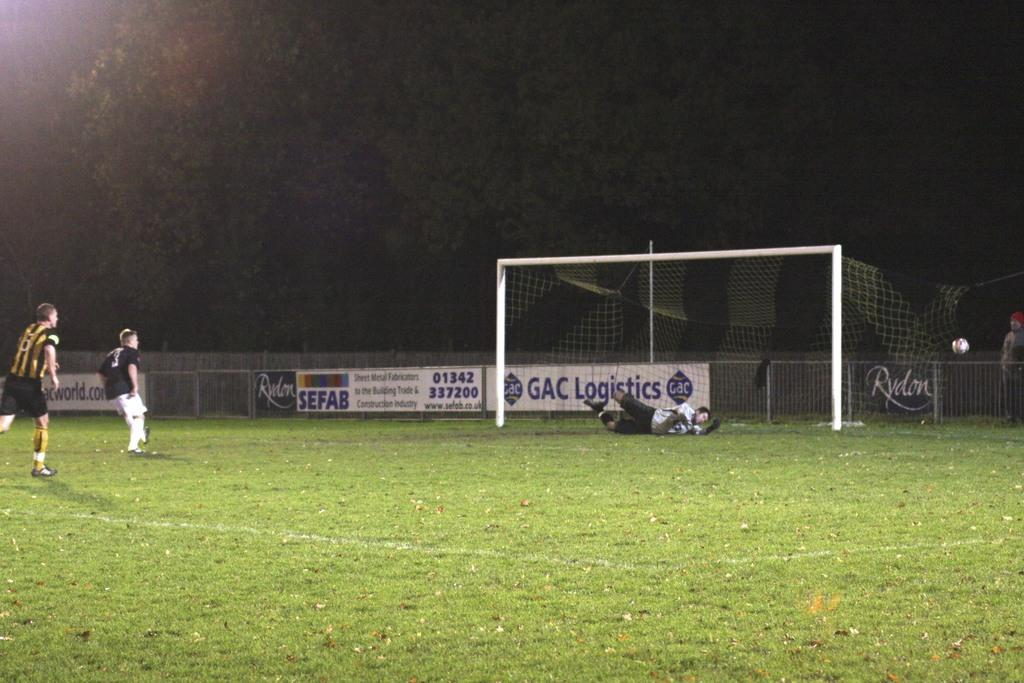<image>
Share a concise interpretation of the image provided. 2 soccer players on the field looking at the goalie making a save, and a sign in the background saying: GAC Logistics. 